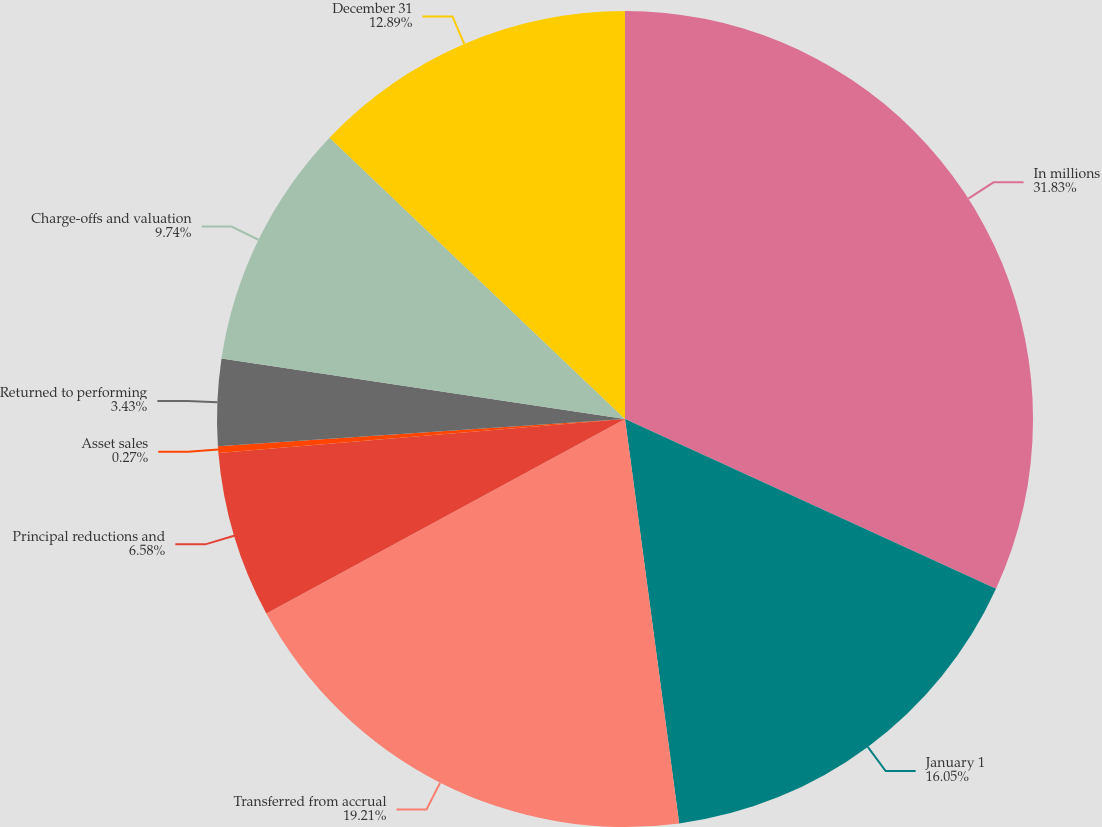Convert chart. <chart><loc_0><loc_0><loc_500><loc_500><pie_chart><fcel>In millions<fcel>January 1<fcel>Transferred from accrual<fcel>Principal reductions and<fcel>Asset sales<fcel>Returned to performing<fcel>Charge-offs and valuation<fcel>December 31<nl><fcel>31.83%<fcel>16.05%<fcel>19.21%<fcel>6.58%<fcel>0.27%<fcel>3.43%<fcel>9.74%<fcel>12.89%<nl></chart> 